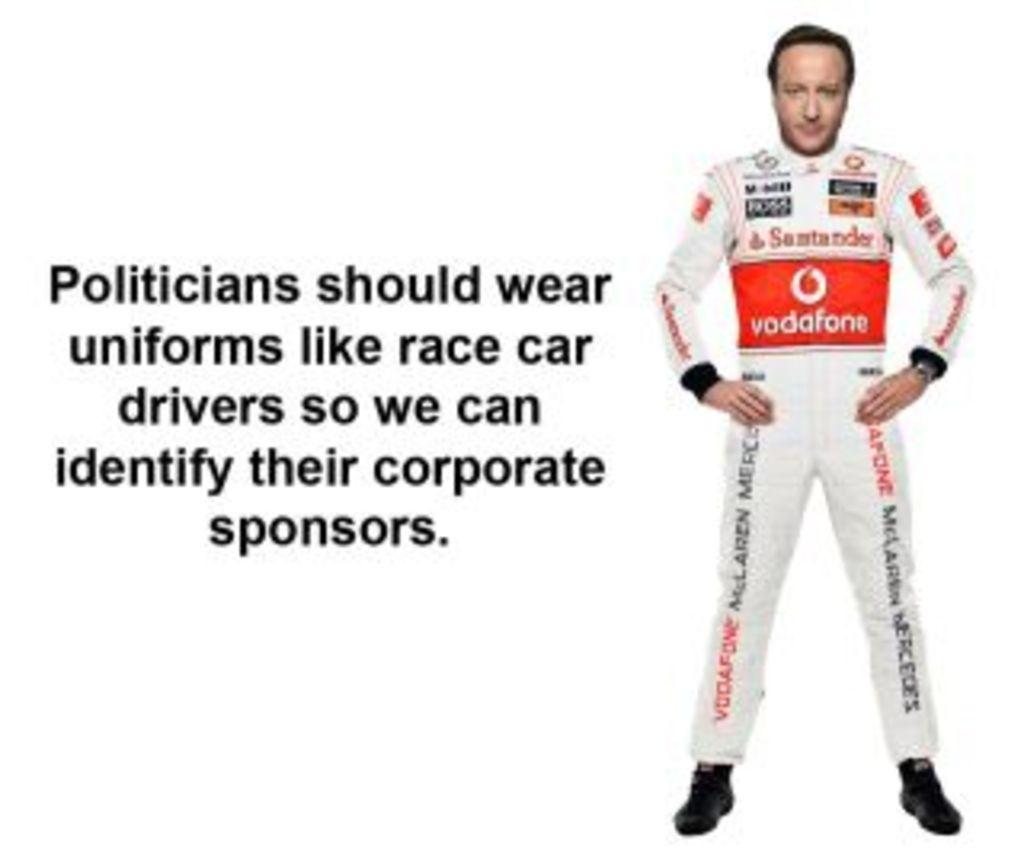<image>
Provide a brief description of the given image. a man with clothing on that has vodafone written on it 